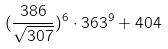Convert formula to latex. <formula><loc_0><loc_0><loc_500><loc_500>( \frac { 3 8 6 } { \sqrt { 3 0 7 } } ) ^ { 6 } \cdot 3 6 3 ^ { 9 } + 4 0 4</formula> 